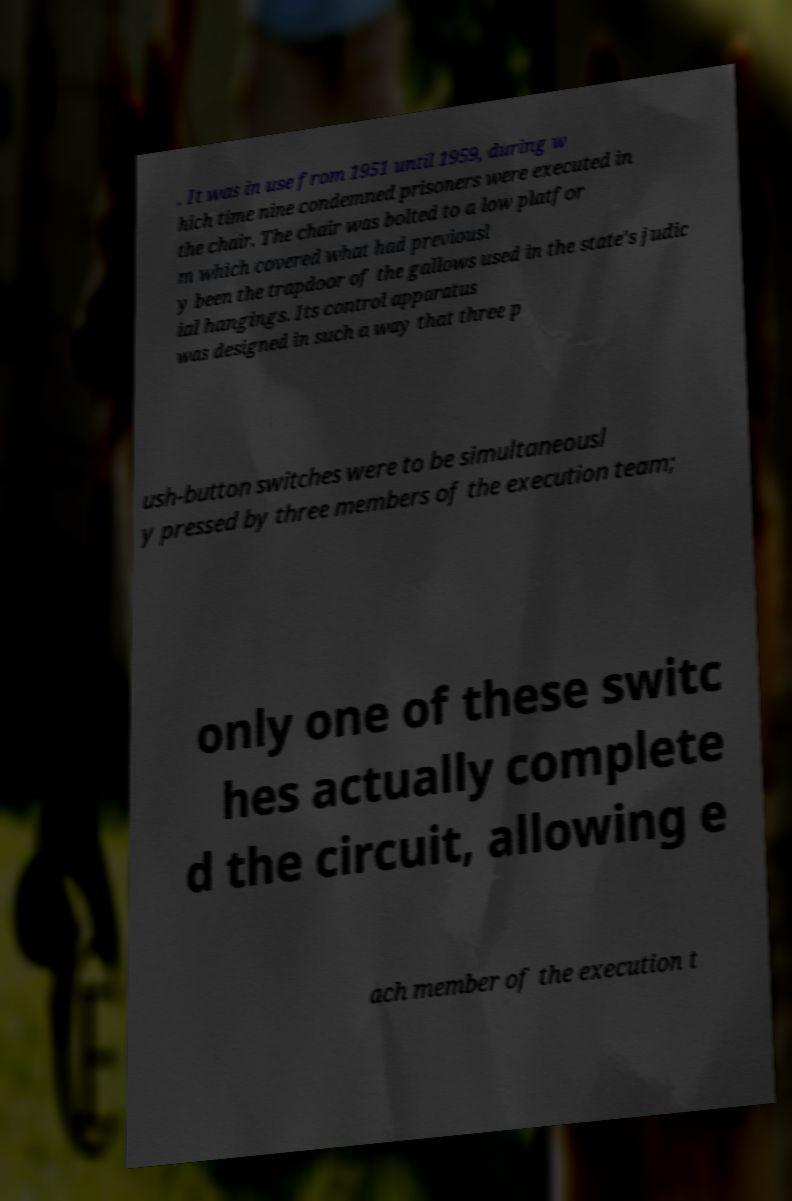I need the written content from this picture converted into text. Can you do that? . It was in use from 1951 until 1959, during w hich time nine condemned prisoners were executed in the chair. The chair was bolted to a low platfor m which covered what had previousl y been the trapdoor of the gallows used in the state's judic ial hangings. Its control apparatus was designed in such a way that three p ush-button switches were to be simultaneousl y pressed by three members of the execution team; only one of these switc hes actually complete d the circuit, allowing e ach member of the execution t 